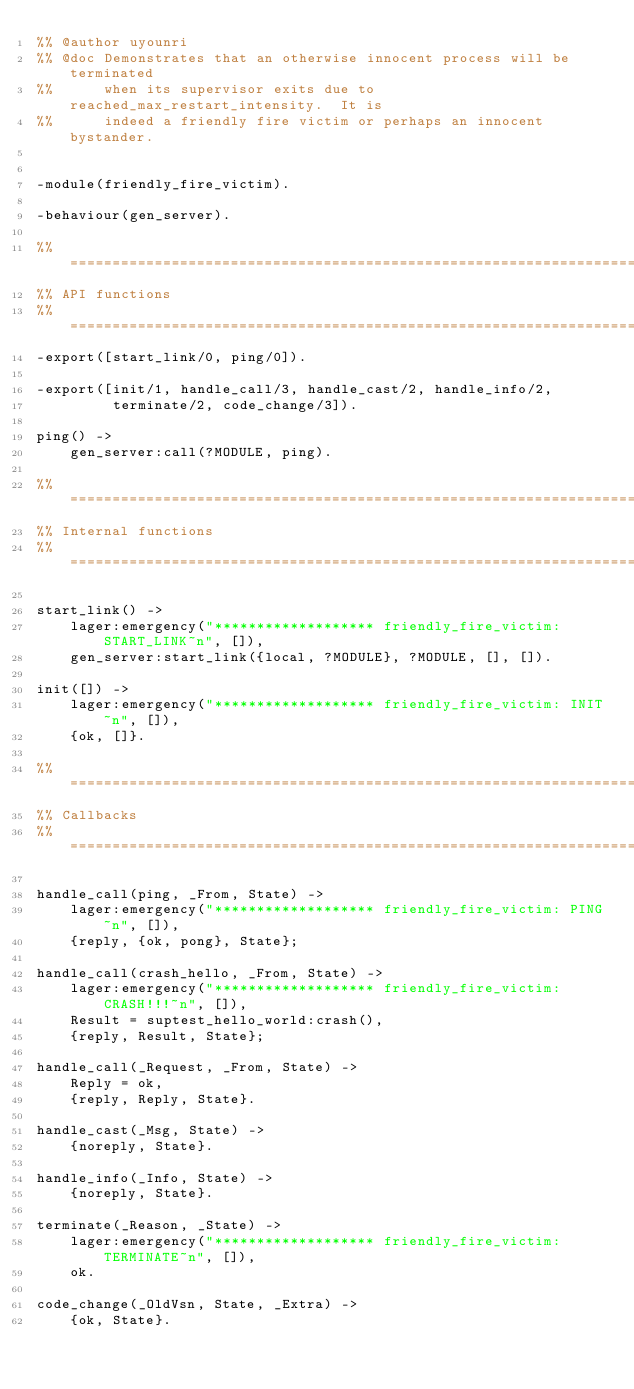<code> <loc_0><loc_0><loc_500><loc_500><_Erlang_>%% @author uyounri
%% @doc Demonstrates that an otherwise innocent process will be terminated
%%		when its supervisor exits due to reached_max_restart_intensity.  It is
%%		indeed a friendly fire victim or perhaps an innocent bystander.


-module(friendly_fire_victim).

-behaviour(gen_server).

%% ====================================================================
%% API functions
%% ====================================================================
-export([start_link/0, ping/0]).

-export([init/1, handle_call/3, handle_cast/2, handle_info/2,
         terminate/2, code_change/3]).

ping() ->
    gen_server:call(?MODULE, ping).

%% ====================================================================
%% Internal functions
%% ====================================================================

start_link() ->
	lager:emergency("******************* friendly_fire_victim: START_LINK~n", []),
    gen_server:start_link({local, ?MODULE}, ?MODULE, [], []).

init([]) ->
	lager:emergency("******************* friendly_fire_victim: INIT~n", []),
    {ok, []}.

%% ====================================================================
%% Callbacks
%% ====================================================================

handle_call(ping, _From, State) ->
    lager:emergency("******************* friendly_fire_victim: PING~n", []),
    {reply, {ok, pong}, State};

handle_call(crash_hello, _From, State) ->
    lager:emergency("******************* friendly_fire_victim: CRASH!!!~n", []),
	Result = suptest_hello_world:crash(),
    {reply, Result, State};

handle_call(_Request, _From, State) ->
    Reply = ok,
    {reply, Reply, State}.

handle_cast(_Msg, State) ->
    {noreply, State}.

handle_info(_Info, State) ->
    {noreply, State}.

terminate(_Reason, _State) ->
	lager:emergency("******************* friendly_fire_victim: TERMINATE~n", []),
    ok.

code_change(_OldVsn, State, _Extra) ->
    {ok, State}.</code> 